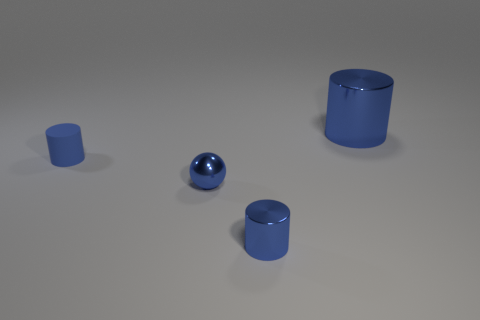Add 3 brown blocks. How many objects exist? 7 Subtract all cylinders. How many objects are left? 1 Subtract all tiny metallic things. Subtract all tiny purple metal cylinders. How many objects are left? 2 Add 3 rubber cylinders. How many rubber cylinders are left? 4 Add 3 cyan metallic spheres. How many cyan metallic spheres exist? 3 Subtract 0 yellow blocks. How many objects are left? 4 